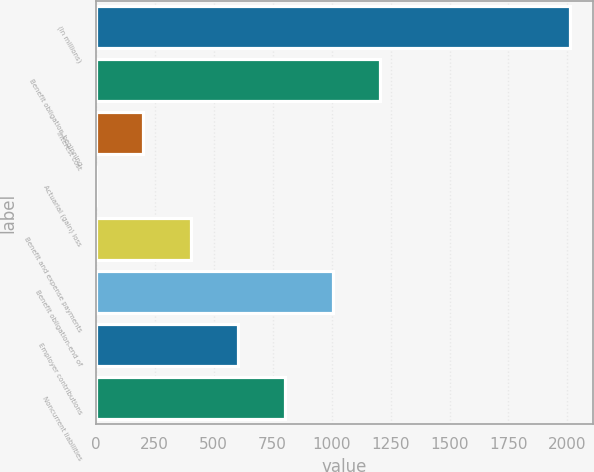<chart> <loc_0><loc_0><loc_500><loc_500><bar_chart><fcel>(In millions)<fcel>Benefit obligation-beginning<fcel>Interest cost<fcel>Actuarial (gain) loss<fcel>Benefit and expense payments<fcel>Benefit obligation-end of<fcel>Employer contributions<fcel>Noncurrent liabilities<nl><fcel>2010<fcel>1206.04<fcel>201.09<fcel>0.1<fcel>402.08<fcel>1005.05<fcel>603.07<fcel>804.06<nl></chart> 